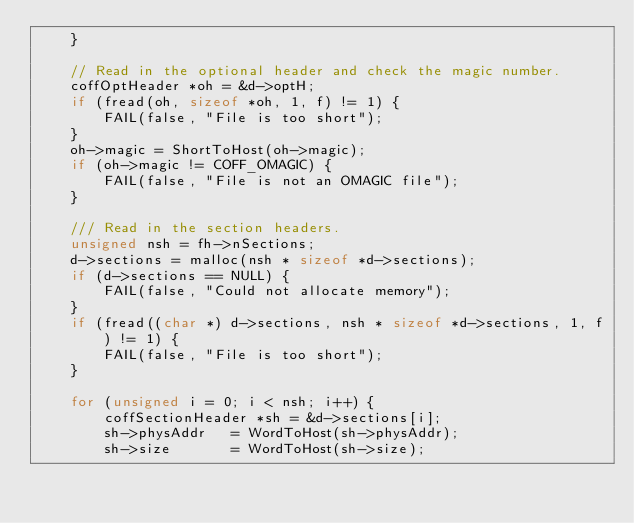Convert code to text. <code><loc_0><loc_0><loc_500><loc_500><_C_>    }

    // Read in the optional header and check the magic number.
    coffOptHeader *oh = &d->optH;
    if (fread(oh, sizeof *oh, 1, f) != 1) {
        FAIL(false, "File is too short");
    }
    oh->magic = ShortToHost(oh->magic);
    if (oh->magic != COFF_OMAGIC) {
        FAIL(false, "File is not an OMAGIC file");
    }

    /// Read in the section headers.
    unsigned nsh = fh->nSections;
    d->sections = malloc(nsh * sizeof *d->sections);
    if (d->sections == NULL) {
        FAIL(false, "Could not allocate memory");
    }
    if (fread((char *) d->sections, nsh * sizeof *d->sections, 1, f) != 1) {
        FAIL(false, "File is too short");
    }

    for (unsigned i = 0; i < nsh; i++) {
        coffSectionHeader *sh = &d->sections[i];
        sh->physAddr   = WordToHost(sh->physAddr);
        sh->size       = WordToHost(sh->size);</code> 